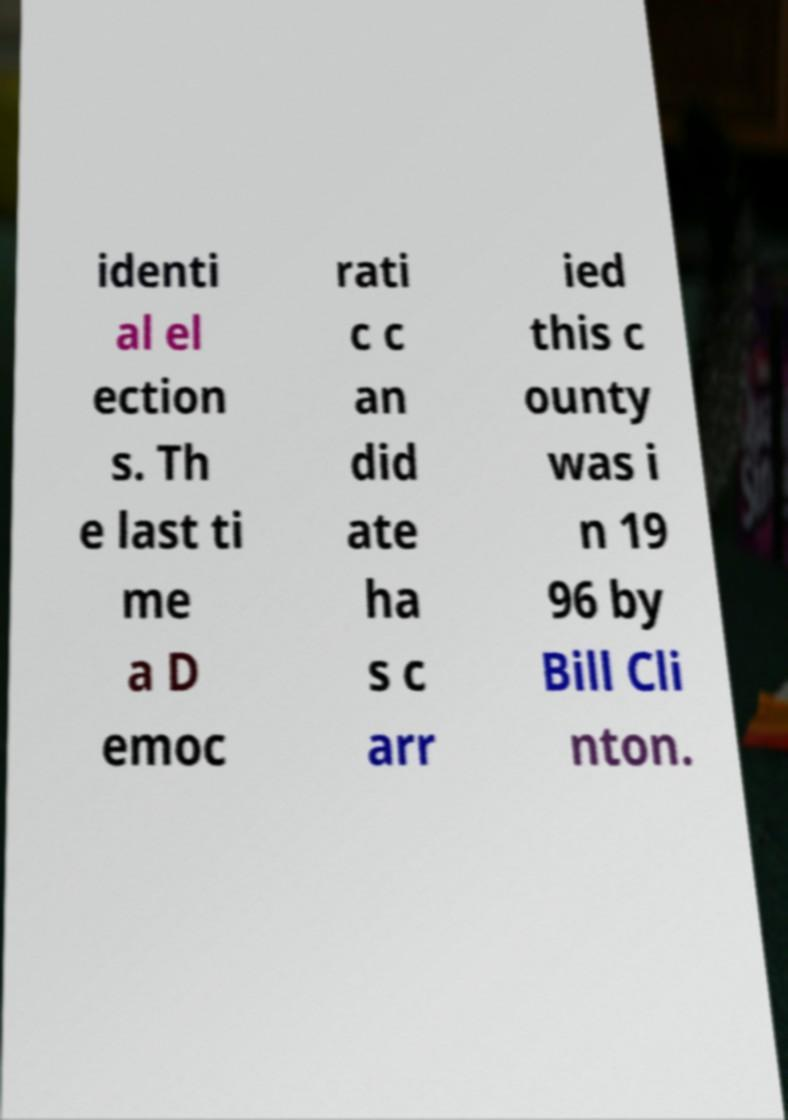Could you assist in decoding the text presented in this image and type it out clearly? identi al el ection s. Th e last ti me a D emoc rati c c an did ate ha s c arr ied this c ounty was i n 19 96 by Bill Cli nton. 